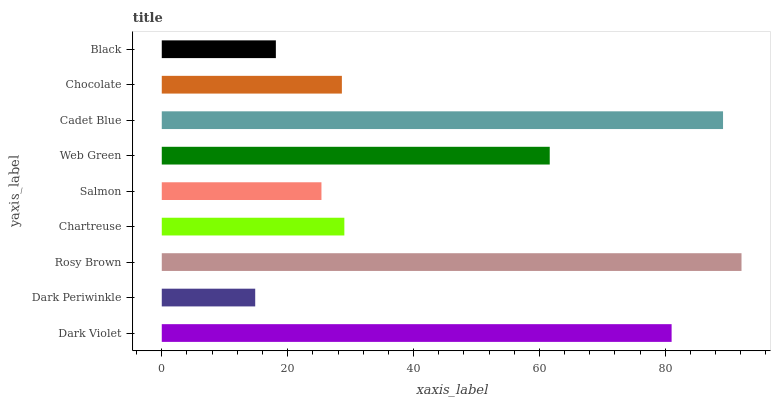Is Dark Periwinkle the minimum?
Answer yes or no. Yes. Is Rosy Brown the maximum?
Answer yes or no. Yes. Is Rosy Brown the minimum?
Answer yes or no. No. Is Dark Periwinkle the maximum?
Answer yes or no. No. Is Rosy Brown greater than Dark Periwinkle?
Answer yes or no. Yes. Is Dark Periwinkle less than Rosy Brown?
Answer yes or no. Yes. Is Dark Periwinkle greater than Rosy Brown?
Answer yes or no. No. Is Rosy Brown less than Dark Periwinkle?
Answer yes or no. No. Is Chartreuse the high median?
Answer yes or no. Yes. Is Chartreuse the low median?
Answer yes or no. Yes. Is Dark Violet the high median?
Answer yes or no. No. Is Dark Periwinkle the low median?
Answer yes or no. No. 